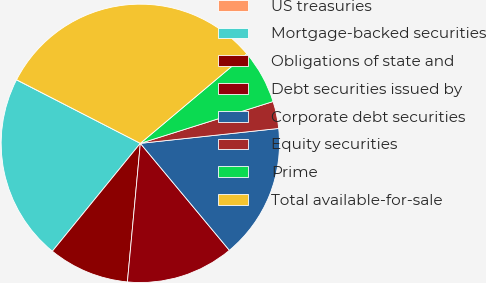Convert chart to OTSL. <chart><loc_0><loc_0><loc_500><loc_500><pie_chart><fcel>US treasuries<fcel>Mortgage-backed securities<fcel>Obligations of state and<fcel>Debt securities issued by<fcel>Corporate debt securities<fcel>Equity securities<fcel>Prime<fcel>Total available-for-sale<nl><fcel>0.02%<fcel>21.65%<fcel>9.41%<fcel>12.53%<fcel>15.66%<fcel>3.15%<fcel>6.28%<fcel>31.31%<nl></chart> 